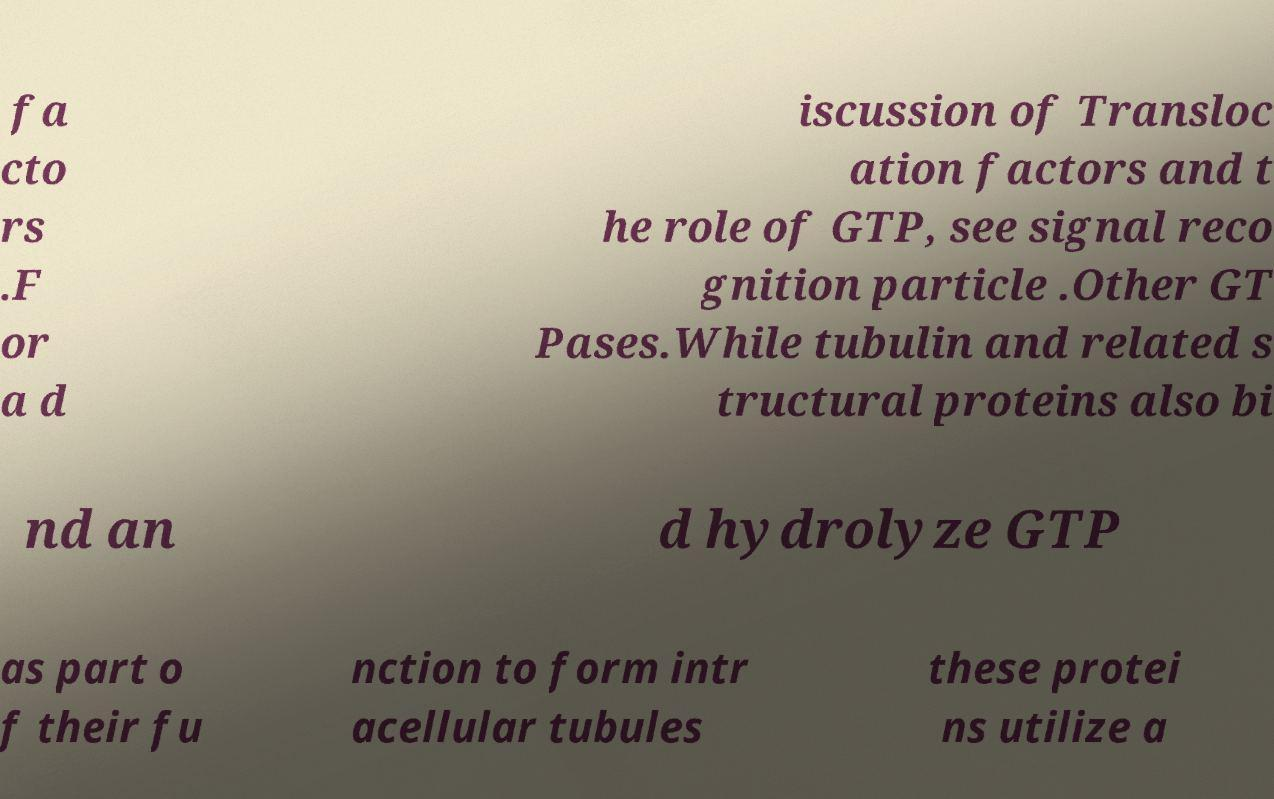Could you extract and type out the text from this image? fa cto rs .F or a d iscussion of Transloc ation factors and t he role of GTP, see signal reco gnition particle .Other GT Pases.While tubulin and related s tructural proteins also bi nd an d hydrolyze GTP as part o f their fu nction to form intr acellular tubules these protei ns utilize a 